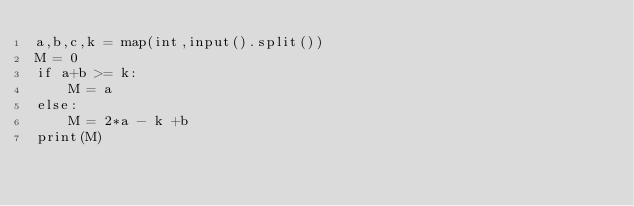<code> <loc_0><loc_0><loc_500><loc_500><_Python_>a,b,c,k = map(int,input().split())
M = 0
if a+b >= k:
    M = a
else:
    M = 2*a - k +b
print(M)</code> 